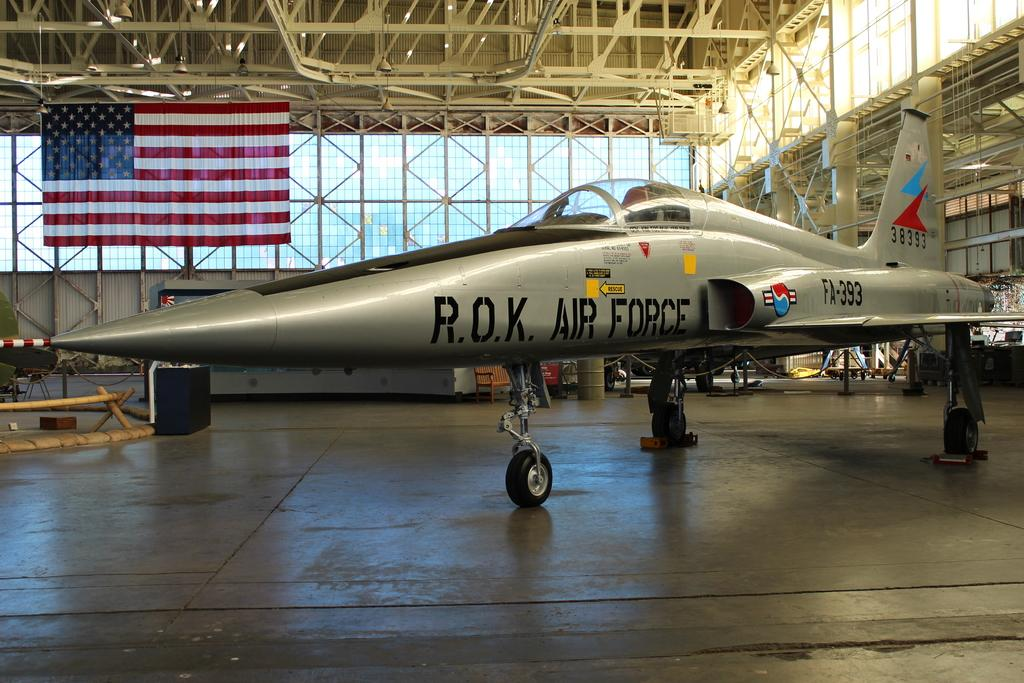<image>
Render a clear and concise summary of the photo. A R.O.K. Air Force aircraft sitting in a hangar 